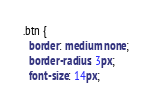<code> <loc_0><loc_0><loc_500><loc_500><_CSS_>.btn {
  border: medium none;
  border-radius: 3px;
  font-size: 14px;</code> 